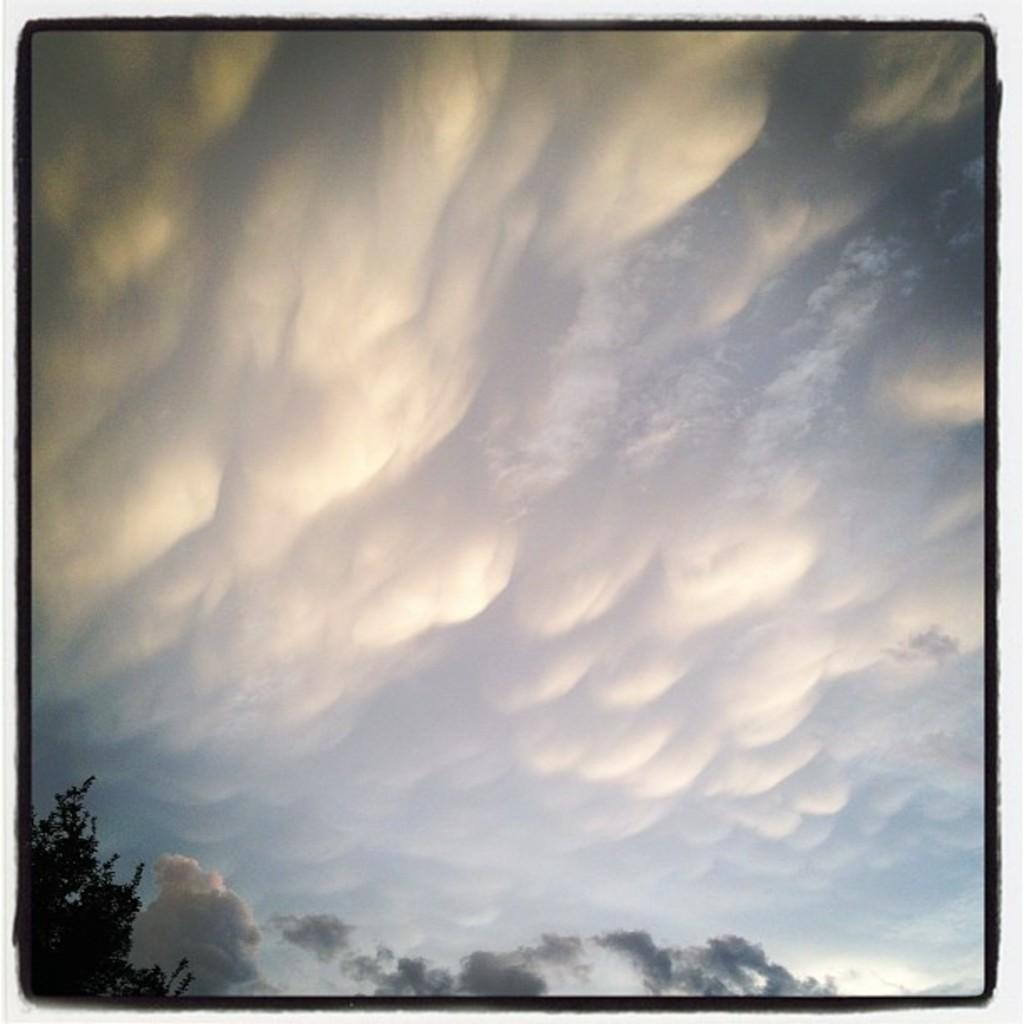What is located on the left side of the image? There is a tree on the left side of the image. What can be seen in the background of the image? There are clouds in the sky in the background of the image. What type of destruction can be seen happening to the tree in the image? There is no destruction happening to the tree in the image; it appears to be standing upright and undamaged. What kind of notebook is lying on the ground near the tree in the image? There is no notebook present in the image; only the tree and clouds in the sky are visible. 